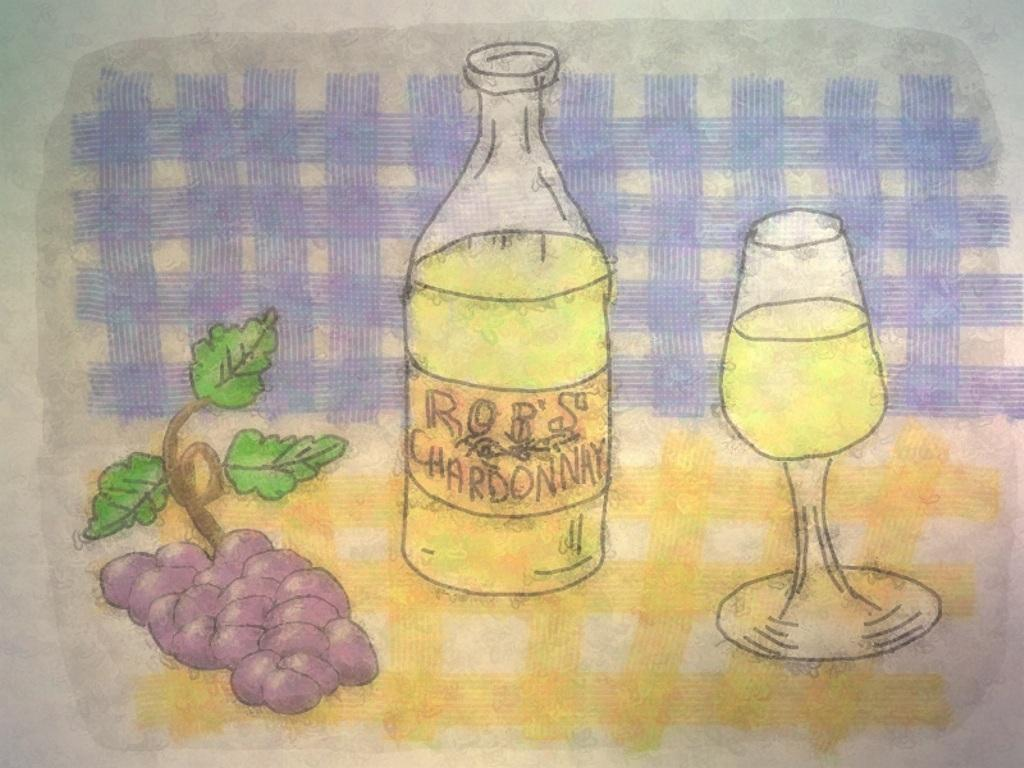What is depicted on the cloth in the image? There are drawings on the cloth in the image. What type of fruit can be seen in the image? There is a bunch of grapes in the image. What beverage-related items are present in the image? There is a wine bottle and a wine glass filled with wine in the image. What type of train is visible in the image? There is no train present in the image. How does the grandfather interact with the drawings on the cloth in the image? There is no grandfather present in the image, and therefore no interaction can be observed. 